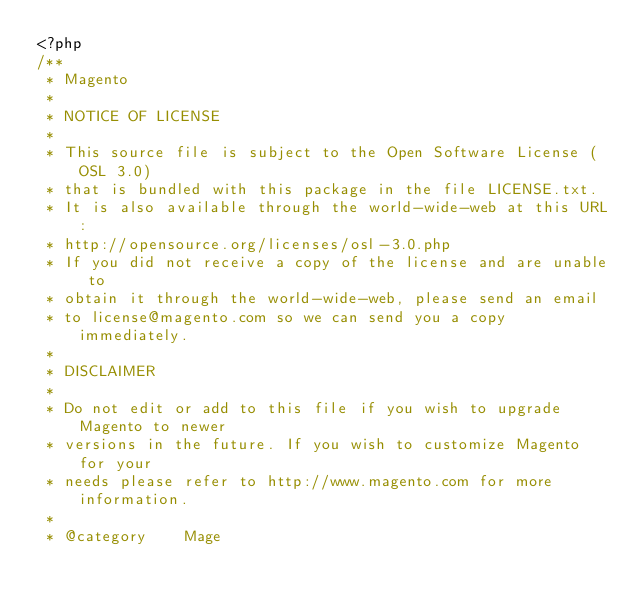Convert code to text. <code><loc_0><loc_0><loc_500><loc_500><_PHP_><?php
/**
 * Magento
 *
 * NOTICE OF LICENSE
 *
 * This source file is subject to the Open Software License (OSL 3.0)
 * that is bundled with this package in the file LICENSE.txt.
 * It is also available through the world-wide-web at this URL:
 * http://opensource.org/licenses/osl-3.0.php
 * If you did not receive a copy of the license and are unable to
 * obtain it through the world-wide-web, please send an email
 * to license@magento.com so we can send you a copy immediately.
 *
 * DISCLAIMER
 *
 * Do not edit or add to this file if you wish to upgrade Magento to newer
 * versions in the future. If you wish to customize Magento for your
 * needs please refer to http://www.magento.com for more information.
 *
 * @category    Mage</code> 